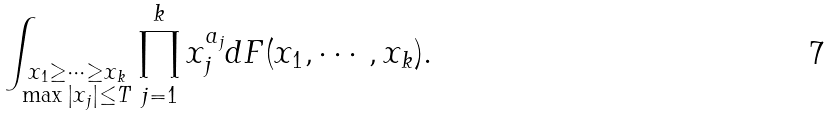<formula> <loc_0><loc_0><loc_500><loc_500>\int _ { \substack { x _ { 1 } \geq \cdots \geq x _ { k } \\ \max { | x _ { j } | } \leq T } } \prod _ { j = 1 } ^ { k } x _ { j } ^ { a _ { j } } d F ( x _ { 1 } , \cdots , x _ { k } ) .</formula> 